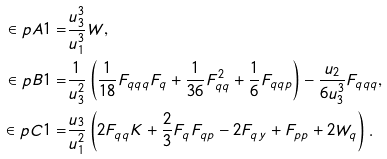Convert formula to latex. <formula><loc_0><loc_0><loc_500><loc_500>\in p { A } { 1 } = & \frac { u _ { 3 } ^ { 3 } } { u ^ { 3 } _ { 1 } } W , \\ \in p { B } { 1 } = & \frac { 1 } { u _ { 3 } ^ { 2 } } \left ( \frac { 1 } { 1 8 } F _ { q q q } F _ { q } + \frac { 1 } { 3 6 } F _ { q q } ^ { 2 } + \frac { 1 } { 6 } F _ { q q p } \right ) - \frac { u _ { 2 } } { 6 u _ { 3 } ^ { 3 } } F _ { q q q } , \\ \in p { C } { 1 } = & \frac { u _ { 3 } } { u _ { 1 } ^ { 2 } } \left ( 2 F _ { q q } K + \frac { 2 } { 3 } F _ { q } F _ { q p } - 2 F _ { q y } + F _ { p p } + 2 W _ { q } \right ) .</formula> 